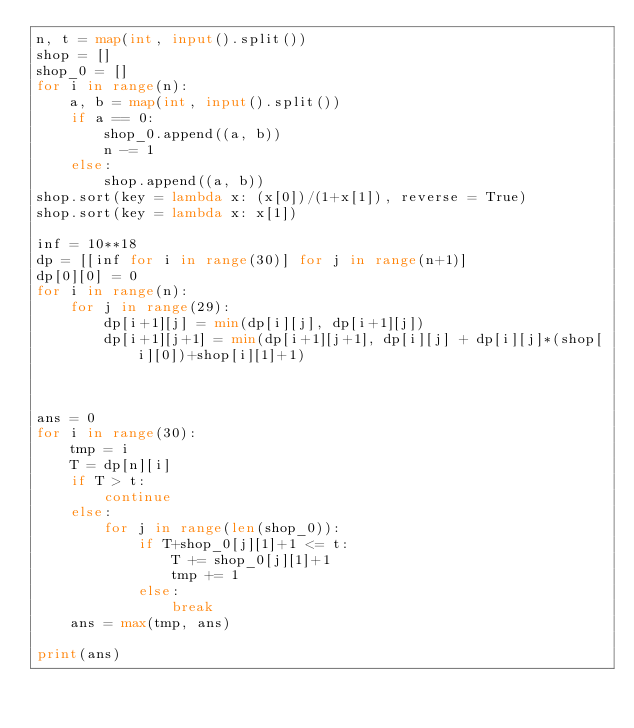<code> <loc_0><loc_0><loc_500><loc_500><_Python_>n, t = map(int, input().split())
shop = []
shop_0 = []
for i in range(n):
    a, b = map(int, input().split())
    if a == 0:
        shop_0.append((a, b))
        n -= 1
    else:
        shop.append((a, b))
shop.sort(key = lambda x: (x[0])/(1+x[1]), reverse = True)
shop.sort(key = lambda x: x[1])

inf = 10**18
dp = [[inf for i in range(30)] for j in range(n+1)]
dp[0][0] = 0
for i in range(n):
    for j in range(29):
        dp[i+1][j] = min(dp[i][j], dp[i+1][j])
        dp[i+1][j+1] = min(dp[i+1][j+1], dp[i][j] + dp[i][j]*(shop[i][0])+shop[i][1]+1)



ans = 0
for i in range(30):
    tmp = i
    T = dp[n][i]
    if T > t:
        continue
    else:
        for j in range(len(shop_0)):
            if T+shop_0[j][1]+1 <= t:
                T += shop_0[j][1]+1
                tmp += 1
            else:
                break
    ans = max(tmp, ans)

print(ans)
</code> 